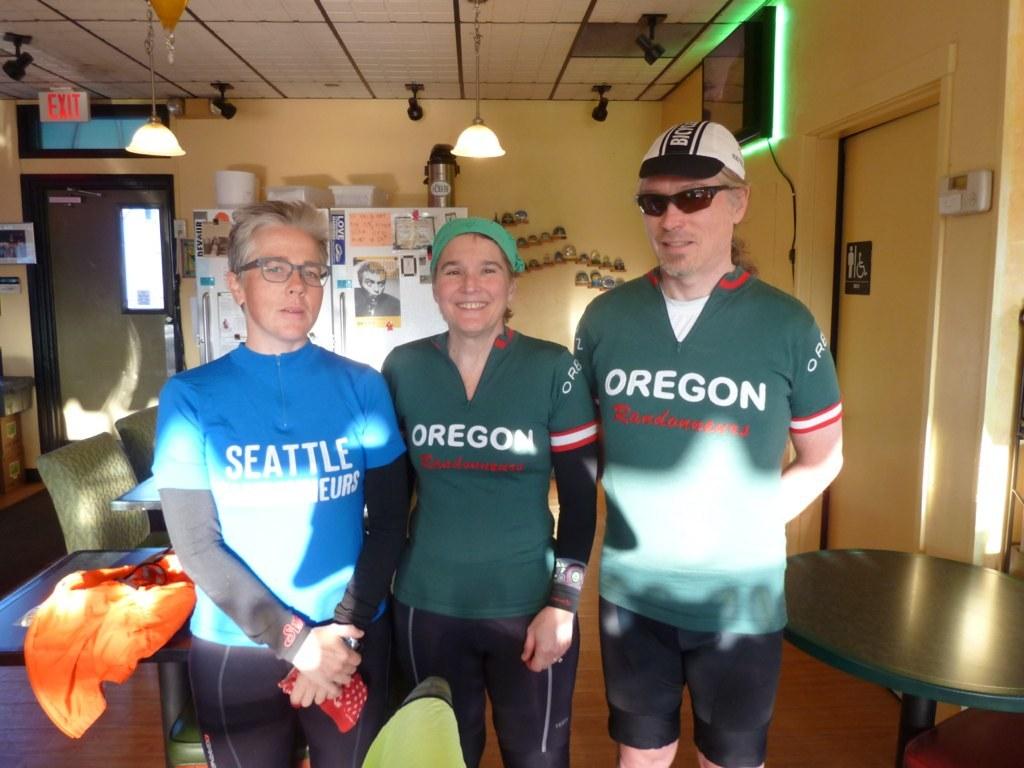What state is on the green outfits?
Your answer should be very brief. Oregon. What city is on the blue shirt?
Your answer should be compact. Seattle. 